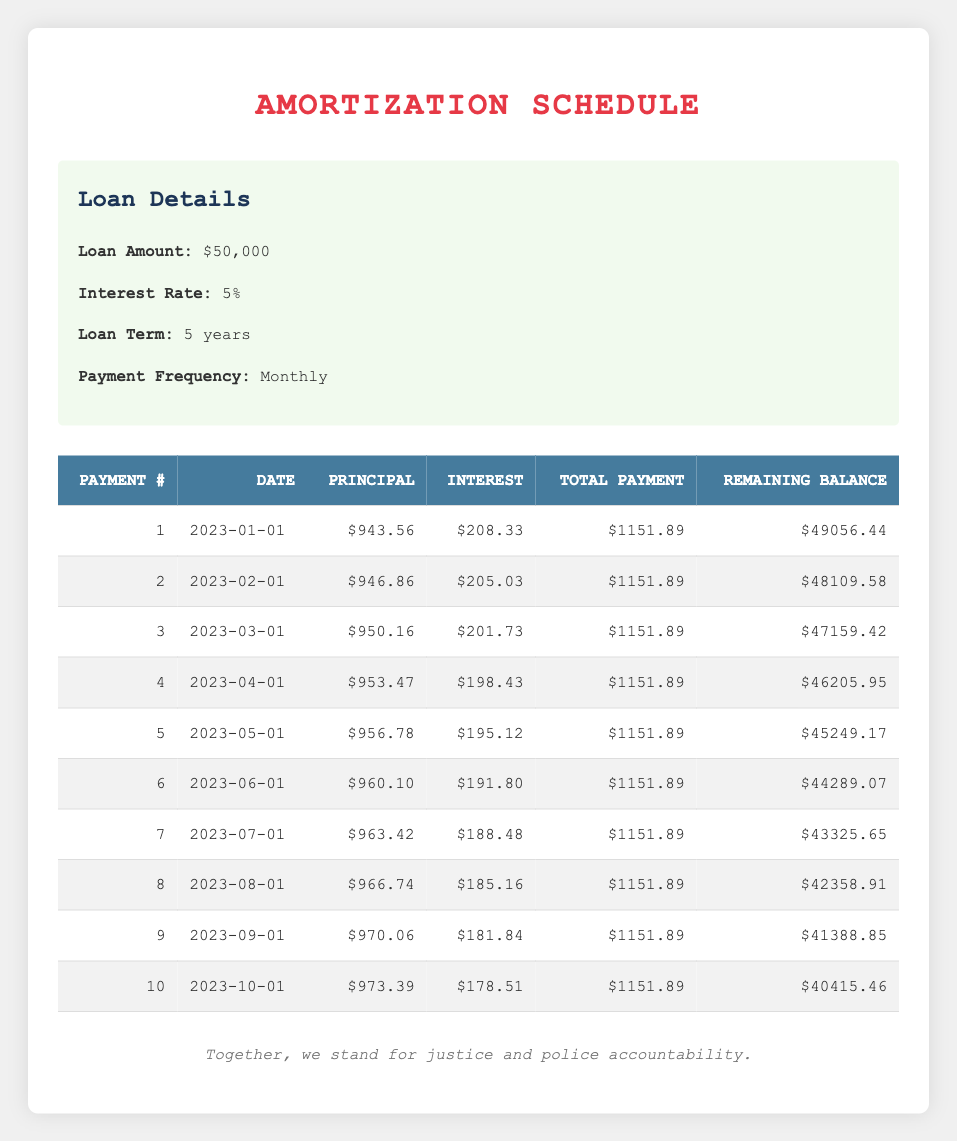What is the total payment amount for the first month? According to the table, the total payment for the first month is listed in the "Total Payment" column for payment number 1, which is $1151.89.
Answer: 1151.89 How much of the second payment was applied to principal? For payment number 2, the "Principal Payment" column shows that $946.86 was applied to principal.
Answer: 946.86 Which payment had the highest interest payment and how much was it? To identify the payment with the highest interest, we look at the "Interest Payment" column across all payments. The highest value is $208.33, which occurs in payment number 1.
Answer: 208.33 What is the total principal paid after the first three payments? To find this, sum the "Principal Payment" values for the first three payments: 943.56 (first payment) + 946.86 (second payment) + 950.16 (third payment) = 2840.58.
Answer: 2840.58 True or false: The remaining balance after the sixth payment is less than $44000. Checking the "Remaining Balance" column, after the sixth payment, the balance is $44289.07, which is greater than $44000. Therefore, the statement is false.
Answer: False What is the average total payment amount for the first five payments? To calculate the average total payment, we sum the "Total Payment" amounts for the first five payments: 1151.89 * 5 = 5759.45, then divide by 5 to find the average: 5759.45 / 5 = 1151.89.
Answer: 1151.89 What is the difference in the principal payments from the first payment to the fifth payment? The principal payment for the first month is $943.56, and for the fifth payment, it's $956.78. The difference is: 956.78 - 943.56 = 13.22.
Answer: 13.22 What was the remaining balance after the third payment? Referring to the "Remaining Balance" column, the balance after the third payment is $47159.42.
Answer: 47159.42 Was the interest payment for the last payment higher than the interest payment for the fifth payment? The "Interest Payment" for the tenth payment is $178.51 and for the fifth payment, it is $195.12. Since $178.51 is less than $195.12, the statement is false.
Answer: False 